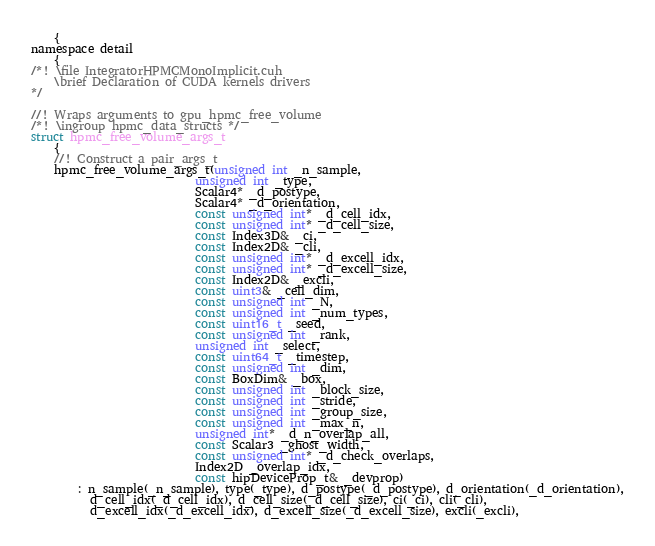Convert code to text. <code><loc_0><loc_0><loc_500><loc_500><_Cuda_>    {
namespace detail
    {
/*! \file IntegratorHPMCMonoImplicit.cuh
    \brief Declaration of CUDA kernels drivers
*/

//! Wraps arguments to gpu_hpmc_free_volume
/*! \ingroup hpmc_data_structs */
struct hpmc_free_volume_args_t
    {
    //! Construct a pair_args_t
    hpmc_free_volume_args_t(unsigned int _n_sample,
                            unsigned int _type,
                            Scalar4* _d_postype,
                            Scalar4* _d_orientation,
                            const unsigned int* _d_cell_idx,
                            const unsigned int* _d_cell_size,
                            const Index3D& _ci,
                            const Index2D& _cli,
                            const unsigned int* _d_excell_idx,
                            const unsigned int* _d_excell_size,
                            const Index2D& _excli,
                            const uint3& _cell_dim,
                            const unsigned int _N,
                            const unsigned int _num_types,
                            const uint16_t _seed,
                            const unsigned int _rank,
                            unsigned int _select,
                            const uint64_t _timestep,
                            const unsigned int _dim,
                            const BoxDim& _box,
                            const unsigned int _block_size,
                            const unsigned int _stride,
                            const unsigned int _group_size,
                            const unsigned int _max_n,
                            unsigned int* _d_n_overlap_all,
                            const Scalar3 _ghost_width,
                            const unsigned int* _d_check_overlaps,
                            Index2D _overlap_idx,
                            const hipDeviceProp_t& _devprop)
        : n_sample(_n_sample), type(_type), d_postype(_d_postype), d_orientation(_d_orientation),
          d_cell_idx(_d_cell_idx), d_cell_size(_d_cell_size), ci(_ci), cli(_cli),
          d_excell_idx(_d_excell_idx), d_excell_size(_d_excell_size), excli(_excli),</code> 